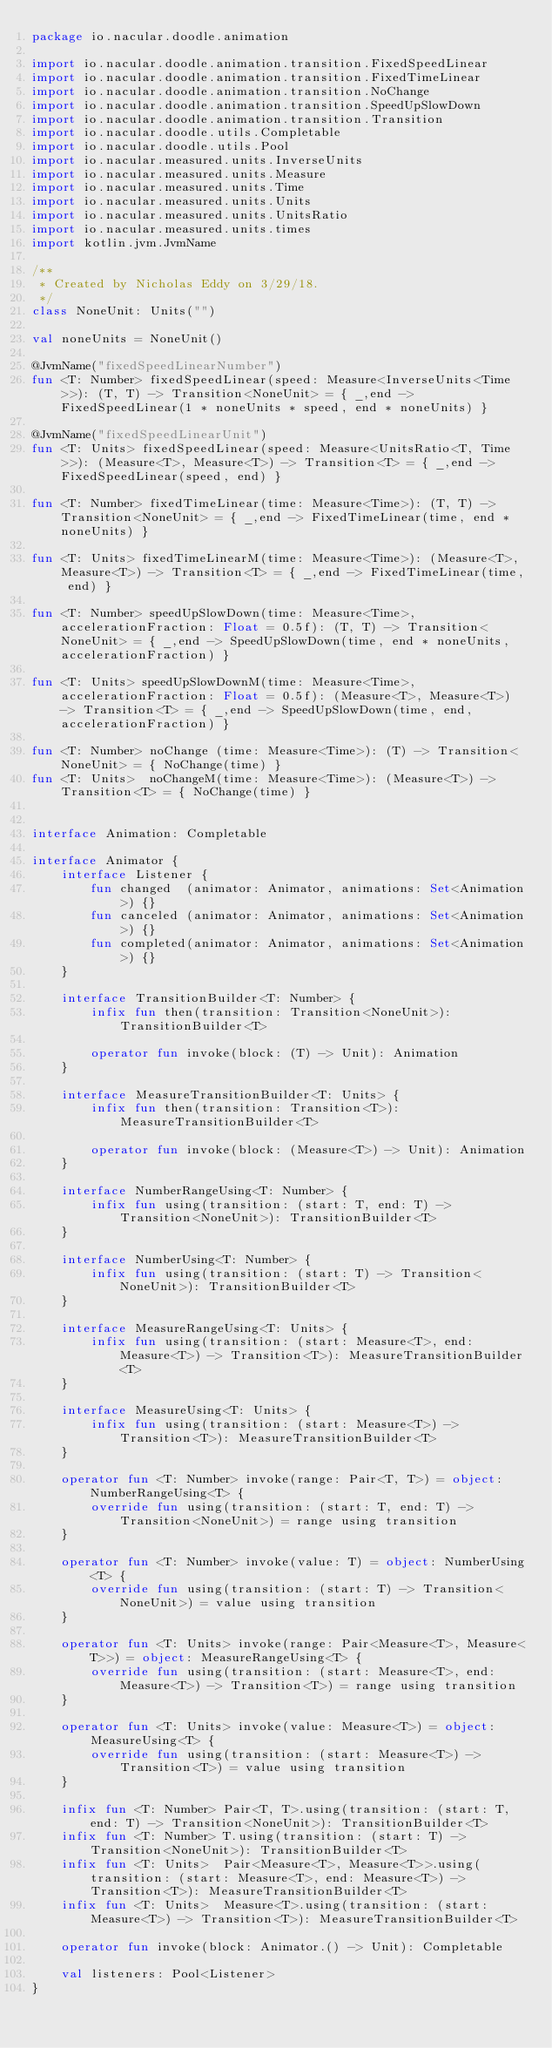Convert code to text. <code><loc_0><loc_0><loc_500><loc_500><_Kotlin_>package io.nacular.doodle.animation

import io.nacular.doodle.animation.transition.FixedSpeedLinear
import io.nacular.doodle.animation.transition.FixedTimeLinear
import io.nacular.doodle.animation.transition.NoChange
import io.nacular.doodle.animation.transition.SpeedUpSlowDown
import io.nacular.doodle.animation.transition.Transition
import io.nacular.doodle.utils.Completable
import io.nacular.doodle.utils.Pool
import io.nacular.measured.units.InverseUnits
import io.nacular.measured.units.Measure
import io.nacular.measured.units.Time
import io.nacular.measured.units.Units
import io.nacular.measured.units.UnitsRatio
import io.nacular.measured.units.times
import kotlin.jvm.JvmName

/**
 * Created by Nicholas Eddy on 3/29/18.
 */
class NoneUnit: Units("")

val noneUnits = NoneUnit()

@JvmName("fixedSpeedLinearNumber")
fun <T: Number> fixedSpeedLinear(speed: Measure<InverseUnits<Time>>): (T, T) -> Transition<NoneUnit> = { _,end -> FixedSpeedLinear(1 * noneUnits * speed, end * noneUnits) }

@JvmName("fixedSpeedLinearUnit")
fun <T: Units> fixedSpeedLinear(speed: Measure<UnitsRatio<T, Time>>): (Measure<T>, Measure<T>) -> Transition<T> = { _,end -> FixedSpeedLinear(speed, end) }

fun <T: Number> fixedTimeLinear(time: Measure<Time>): (T, T) -> Transition<NoneUnit> = { _,end -> FixedTimeLinear(time, end * noneUnits) }

fun <T: Units> fixedTimeLinearM(time: Measure<Time>): (Measure<T>, Measure<T>) -> Transition<T> = { _,end -> FixedTimeLinear(time, end) }

fun <T: Number> speedUpSlowDown(time: Measure<Time>, accelerationFraction: Float = 0.5f): (T, T) -> Transition<NoneUnit> = { _,end -> SpeedUpSlowDown(time, end * noneUnits, accelerationFraction) }

fun <T: Units> speedUpSlowDownM(time: Measure<Time>, accelerationFraction: Float = 0.5f): (Measure<T>, Measure<T>) -> Transition<T> = { _,end -> SpeedUpSlowDown(time, end, accelerationFraction) }

fun <T: Number> noChange (time: Measure<Time>): (T) -> Transition<NoneUnit> = { NoChange(time) }
fun <T: Units>  noChangeM(time: Measure<Time>): (Measure<T>) -> Transition<T> = { NoChange(time) }


interface Animation: Completable

interface Animator {
    interface Listener {
        fun changed  (animator: Animator, animations: Set<Animation>) {}
        fun canceled (animator: Animator, animations: Set<Animation>) {}
        fun completed(animator: Animator, animations: Set<Animation>) {}
    }

    interface TransitionBuilder<T: Number> {
        infix fun then(transition: Transition<NoneUnit>): TransitionBuilder<T>

        operator fun invoke(block: (T) -> Unit): Animation
    }

    interface MeasureTransitionBuilder<T: Units> {
        infix fun then(transition: Transition<T>): MeasureTransitionBuilder<T>

        operator fun invoke(block: (Measure<T>) -> Unit): Animation
    }

    interface NumberRangeUsing<T: Number> {
        infix fun using(transition: (start: T, end: T) -> Transition<NoneUnit>): TransitionBuilder<T>
    }

    interface NumberUsing<T: Number> {
        infix fun using(transition: (start: T) -> Transition<NoneUnit>): TransitionBuilder<T>
    }

    interface MeasureRangeUsing<T: Units> {
        infix fun using(transition: (start: Measure<T>, end: Measure<T>) -> Transition<T>): MeasureTransitionBuilder<T>
    }

    interface MeasureUsing<T: Units> {
        infix fun using(transition: (start: Measure<T>) -> Transition<T>): MeasureTransitionBuilder<T>
    }

    operator fun <T: Number> invoke(range: Pair<T, T>) = object: NumberRangeUsing<T> {
        override fun using(transition: (start: T, end: T) -> Transition<NoneUnit>) = range using transition
    }

    operator fun <T: Number> invoke(value: T) = object: NumberUsing<T> {
        override fun using(transition: (start: T) -> Transition<NoneUnit>) = value using transition
    }

    operator fun <T: Units> invoke(range: Pair<Measure<T>, Measure<T>>) = object: MeasureRangeUsing<T> {
        override fun using(transition: (start: Measure<T>, end: Measure<T>) -> Transition<T>) = range using transition
    }

    operator fun <T: Units> invoke(value: Measure<T>) = object: MeasureUsing<T> {
        override fun using(transition: (start: Measure<T>) -> Transition<T>) = value using transition
    }

    infix fun <T: Number> Pair<T, T>.using(transition: (start: T, end: T) -> Transition<NoneUnit>): TransitionBuilder<T>
    infix fun <T: Number> T.using(transition: (start: T) -> Transition<NoneUnit>): TransitionBuilder<T>
    infix fun <T: Units>  Pair<Measure<T>, Measure<T>>.using(transition: (start: Measure<T>, end: Measure<T>) -> Transition<T>): MeasureTransitionBuilder<T>
    infix fun <T: Units>  Measure<T>.using(transition: (start: Measure<T>) -> Transition<T>): MeasureTransitionBuilder<T>

    operator fun invoke(block: Animator.() -> Unit): Completable

    val listeners: Pool<Listener>
}</code> 